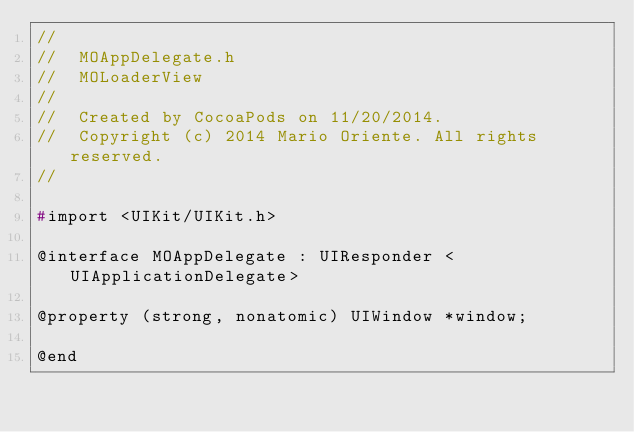<code> <loc_0><loc_0><loc_500><loc_500><_C_>//
//  MOAppDelegate.h
//  MOLoaderView
//
//  Created by CocoaPods on 11/20/2014.
//  Copyright (c) 2014 Mario Oriente. All rights reserved.
//

#import <UIKit/UIKit.h>

@interface MOAppDelegate : UIResponder <UIApplicationDelegate>

@property (strong, nonatomic) UIWindow *window;

@end
</code> 